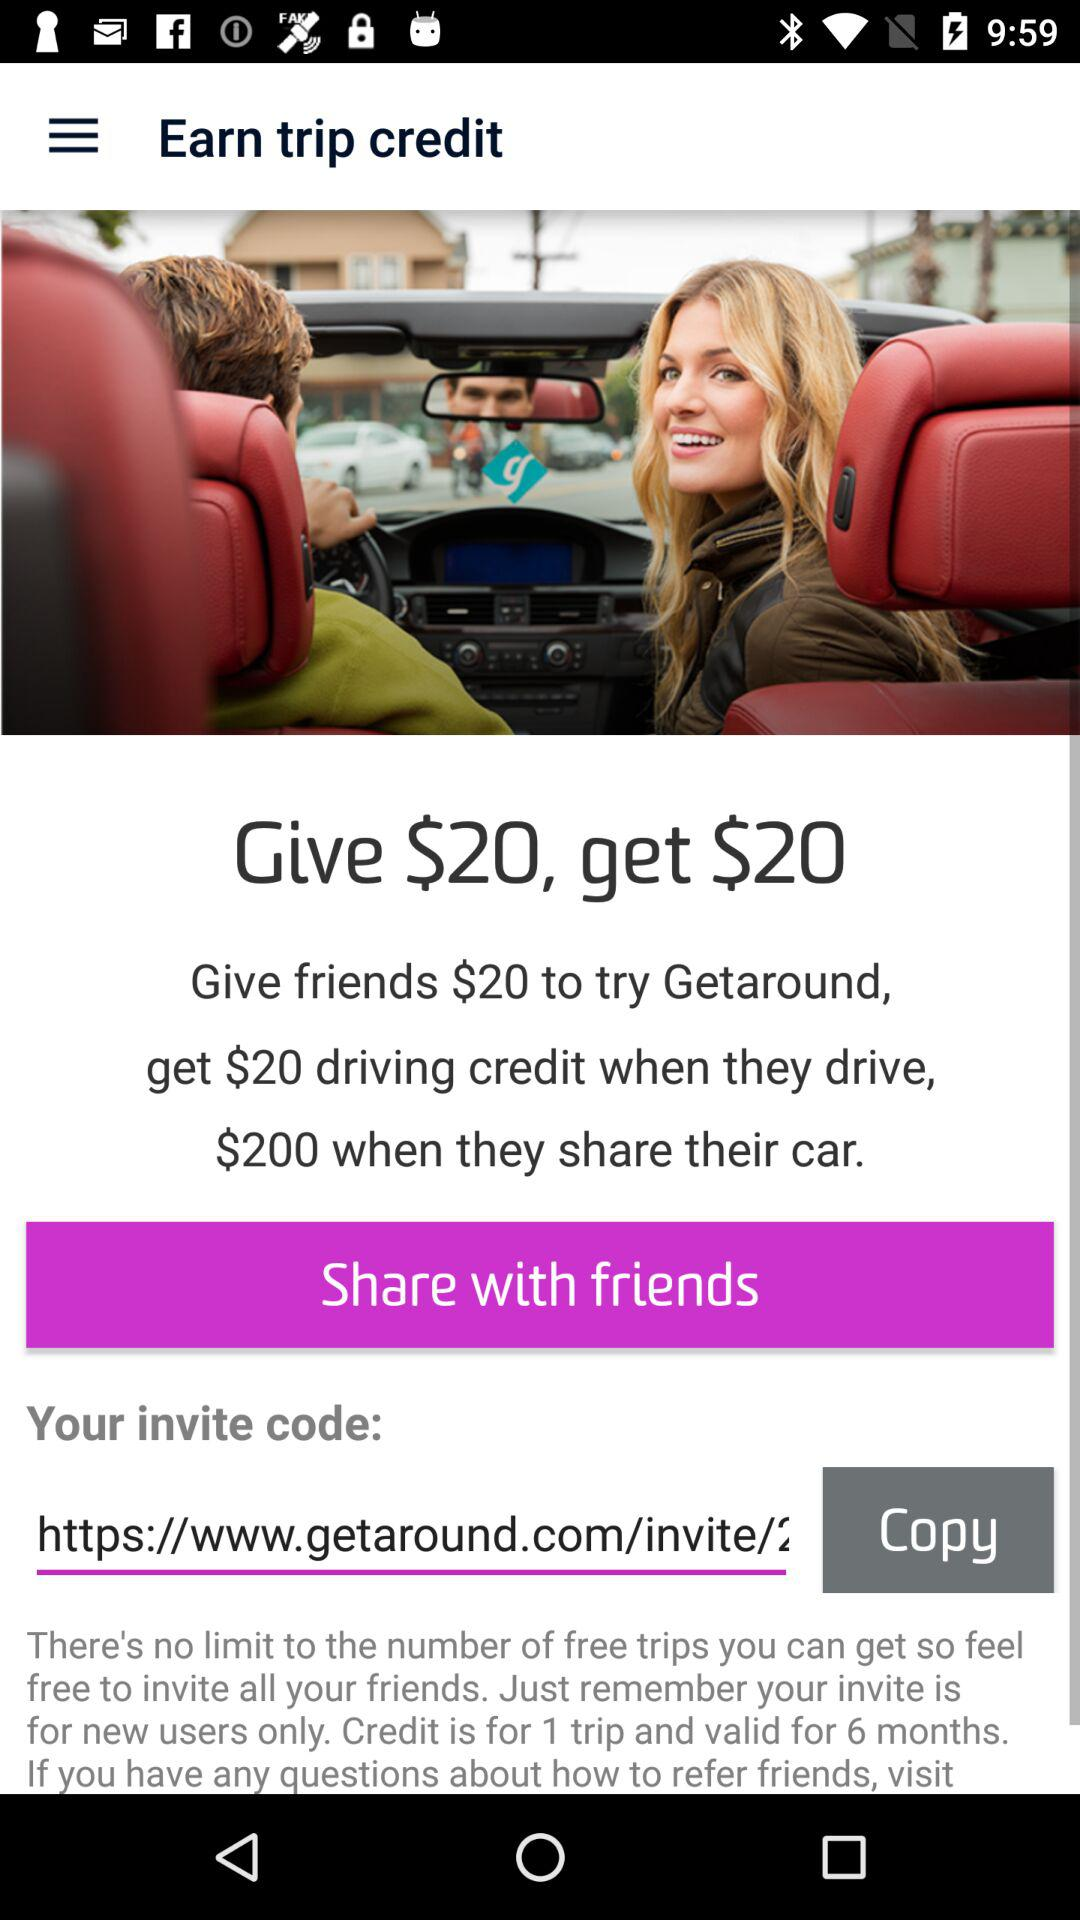What is the invite code?
When the provided information is insufficient, respond with <no answer>. <no answer> 